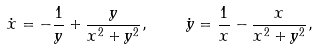<formula> <loc_0><loc_0><loc_500><loc_500>\dot { x } = - \frac { 1 } { y } + \frac { y } { x ^ { 2 } + y ^ { 2 } } , \quad \dot { y } = \frac { 1 } { x } - \frac { x } { x ^ { 2 } + y ^ { 2 } } ,</formula> 